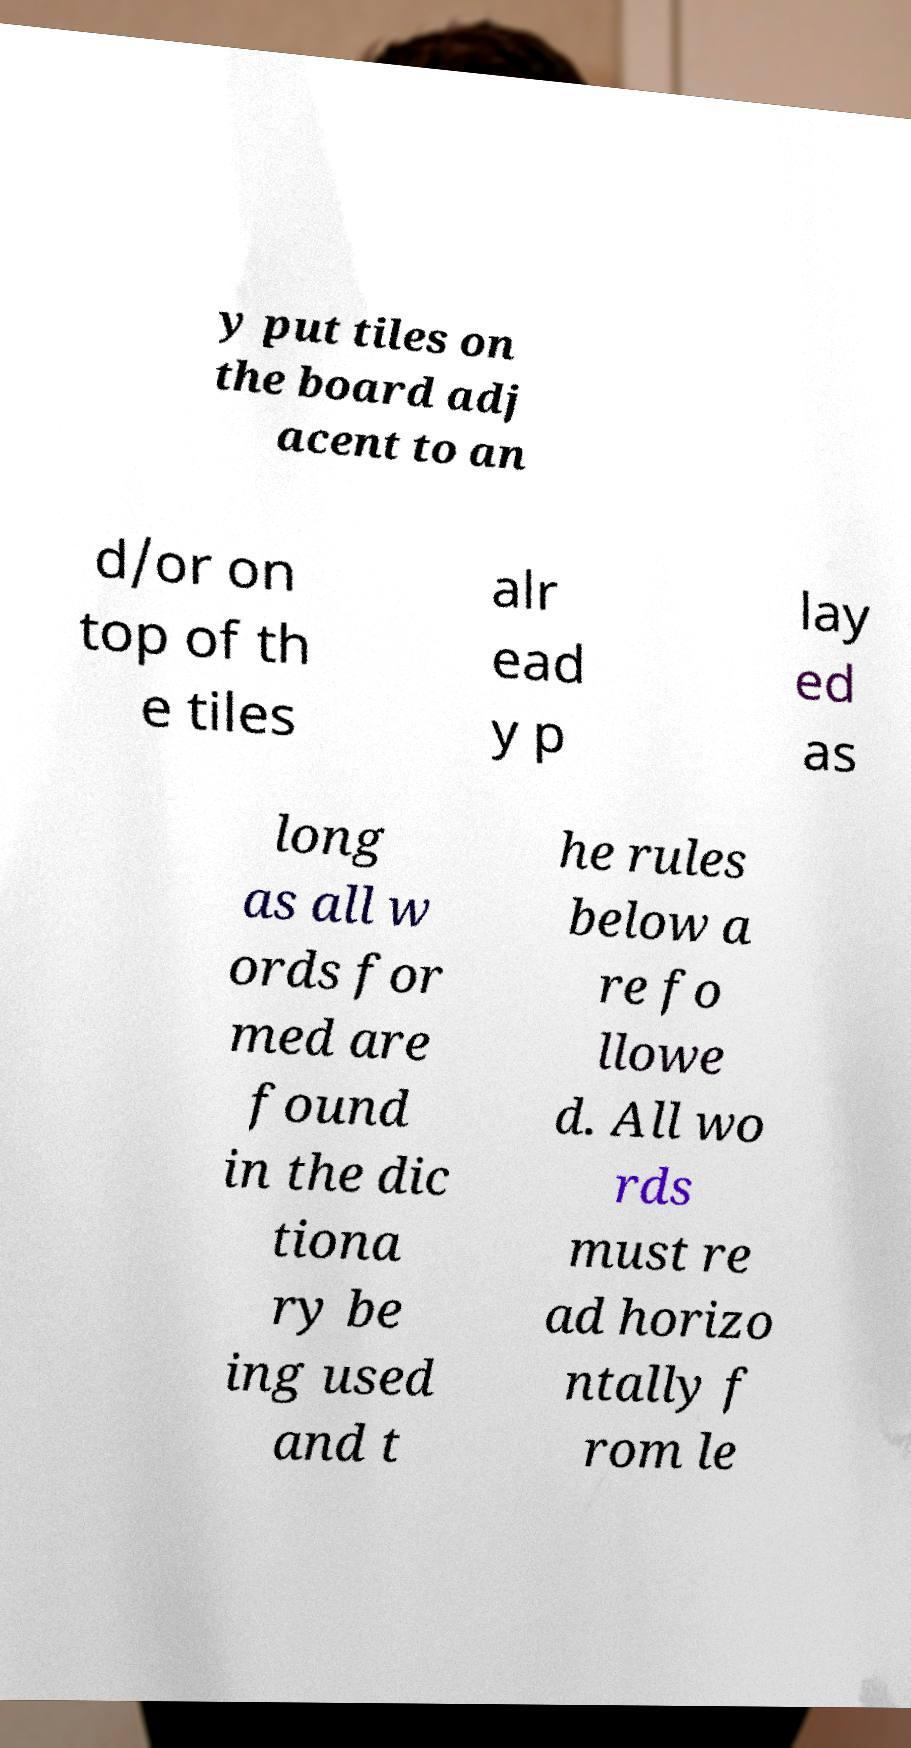What messages or text are displayed in this image? I need them in a readable, typed format. y put tiles on the board adj acent to an d/or on top of th e tiles alr ead y p lay ed as long as all w ords for med are found in the dic tiona ry be ing used and t he rules below a re fo llowe d. All wo rds must re ad horizo ntally f rom le 